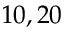Convert formula to latex. <formula><loc_0><loc_0><loc_500><loc_500>1 0 , 2 0</formula> 